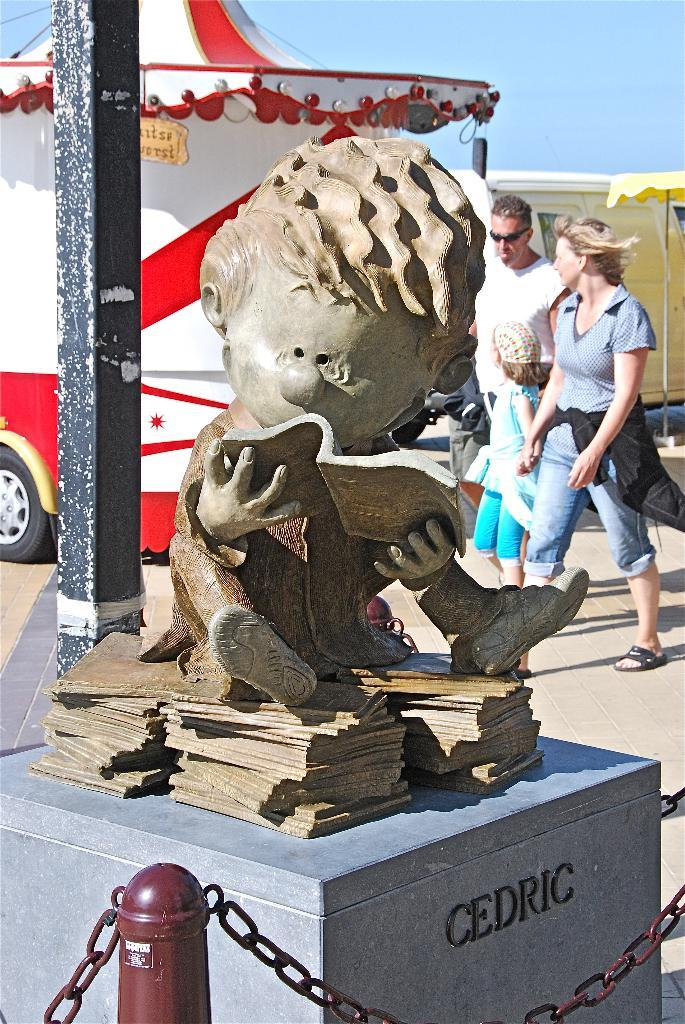What is the main object in the center of the image? There is a pole in the center of the image. What is on top of the pole? There is a statue on the pole. What can be seen in the background of the image? There are vehicles and persons in the background of the image. What is visible in the sky in the image? The sky is visible in the background of the image. What type of cake is being served at the event in the image? There is no event or cake present in the image; it features a pole with a statue and a background with vehicles and persons. How many legs does the statue have in the image? The provided facts do not mention the number of legs the statue has, so it cannot be determined from the image. 